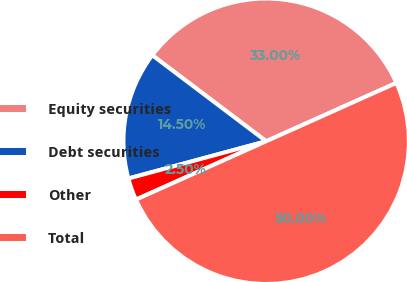Convert chart to OTSL. <chart><loc_0><loc_0><loc_500><loc_500><pie_chart><fcel>Equity securities<fcel>Debt securities<fcel>Other<fcel>Total<nl><fcel>33.0%<fcel>14.5%<fcel>2.5%<fcel>50.0%<nl></chart> 